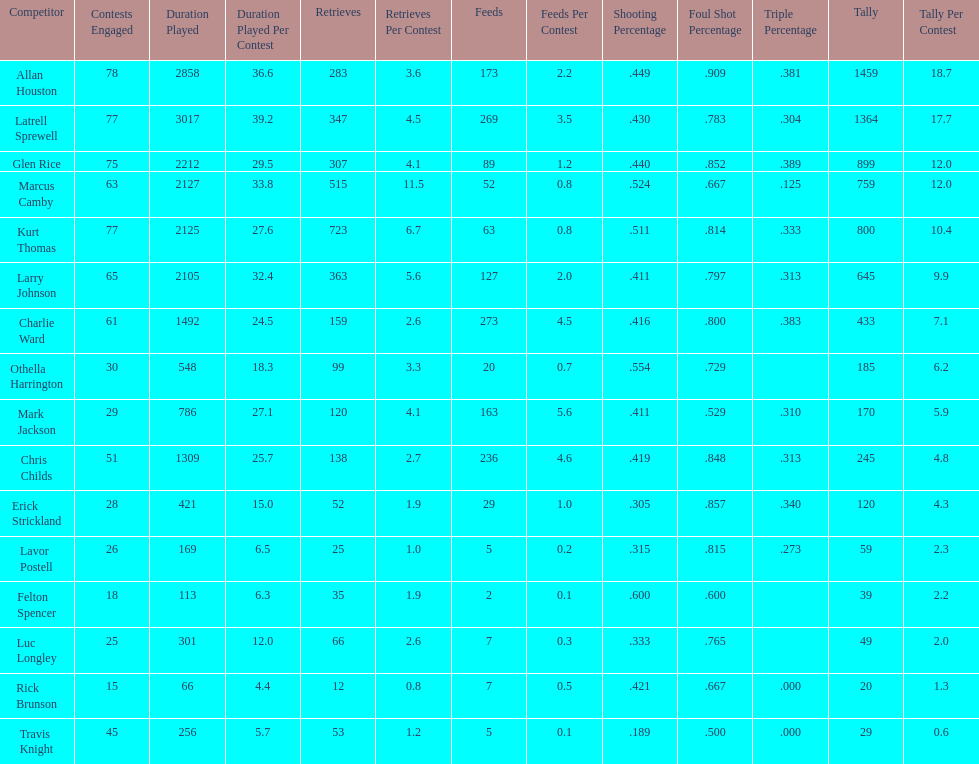Give the number of players covered by the table. 16. 